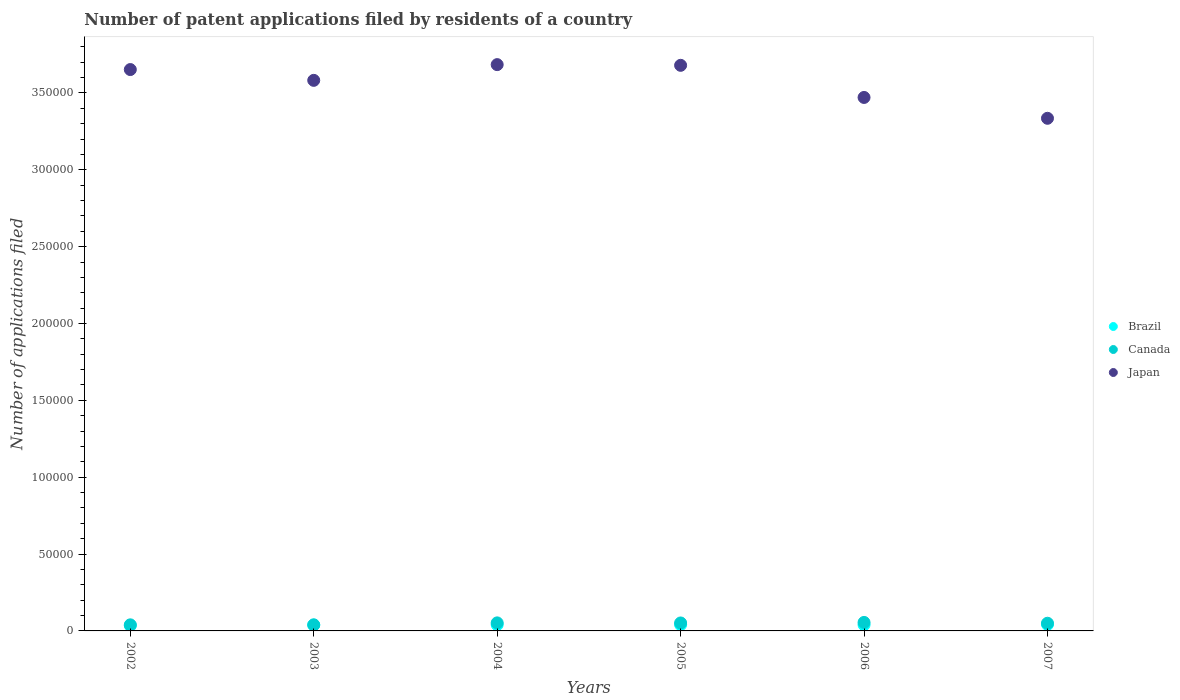What is the number of applications filed in Canada in 2004?
Your answer should be compact. 5231. Across all years, what is the maximum number of applications filed in Japan?
Ensure brevity in your answer.  3.68e+05. Across all years, what is the minimum number of applications filed in Japan?
Your answer should be very brief. 3.33e+05. In which year was the number of applications filed in Canada maximum?
Ensure brevity in your answer.  2006. What is the total number of applications filed in Brazil in the graph?
Your response must be concise. 2.36e+04. What is the difference between the number of applications filed in Brazil in 2003 and that in 2005?
Your response must be concise. -188. What is the difference between the number of applications filed in Brazil in 2004 and the number of applications filed in Canada in 2002?
Provide a short and direct response. 85. What is the average number of applications filed in Brazil per year?
Your answer should be compact. 3932.5. In the year 2006, what is the difference between the number of applications filed in Brazil and number of applications filed in Canada?
Provide a short and direct response. -1566. What is the ratio of the number of applications filed in Brazil in 2004 to that in 2006?
Your response must be concise. 1.02. What is the difference between the highest and the second highest number of applications filed in Japan?
Keep it short and to the point. 456. What is the difference between the highest and the lowest number of applications filed in Japan?
Provide a short and direct response. 3.49e+04. Is the number of applications filed in Japan strictly less than the number of applications filed in Canada over the years?
Offer a terse response. No. How many dotlines are there?
Your answer should be very brief. 3. What is the difference between two consecutive major ticks on the Y-axis?
Your response must be concise. 5.00e+04. Are the values on the major ticks of Y-axis written in scientific E-notation?
Provide a succinct answer. No. Does the graph contain any zero values?
Give a very brief answer. No. Where does the legend appear in the graph?
Offer a terse response. Center right. How many legend labels are there?
Your answer should be compact. 3. How are the legend labels stacked?
Offer a very short reply. Vertical. What is the title of the graph?
Make the answer very short. Number of patent applications filed by residents of a country. What is the label or title of the X-axis?
Keep it short and to the point. Years. What is the label or title of the Y-axis?
Offer a terse response. Number of applications filed. What is the Number of applications filed of Brazil in 2002?
Your answer should be very brief. 3481. What is the Number of applications filed in Canada in 2002?
Your answer should be very brief. 3959. What is the Number of applications filed in Japan in 2002?
Offer a terse response. 3.65e+05. What is the Number of applications filed of Brazil in 2003?
Offer a terse response. 3866. What is the Number of applications filed of Canada in 2003?
Your answer should be compact. 3929. What is the Number of applications filed in Japan in 2003?
Offer a terse response. 3.58e+05. What is the Number of applications filed in Brazil in 2004?
Give a very brief answer. 4044. What is the Number of applications filed of Canada in 2004?
Provide a succinct answer. 5231. What is the Number of applications filed of Japan in 2004?
Your response must be concise. 3.68e+05. What is the Number of applications filed in Brazil in 2005?
Provide a short and direct response. 4054. What is the Number of applications filed in Canada in 2005?
Keep it short and to the point. 5183. What is the Number of applications filed of Japan in 2005?
Your response must be concise. 3.68e+05. What is the Number of applications filed in Brazil in 2006?
Your answer should be very brief. 3956. What is the Number of applications filed of Canada in 2006?
Keep it short and to the point. 5522. What is the Number of applications filed in Japan in 2006?
Give a very brief answer. 3.47e+05. What is the Number of applications filed of Brazil in 2007?
Your answer should be very brief. 4194. What is the Number of applications filed of Canada in 2007?
Make the answer very short. 4998. What is the Number of applications filed in Japan in 2007?
Make the answer very short. 3.33e+05. Across all years, what is the maximum Number of applications filed in Brazil?
Offer a terse response. 4194. Across all years, what is the maximum Number of applications filed of Canada?
Provide a succinct answer. 5522. Across all years, what is the maximum Number of applications filed in Japan?
Give a very brief answer. 3.68e+05. Across all years, what is the minimum Number of applications filed of Brazil?
Provide a succinct answer. 3481. Across all years, what is the minimum Number of applications filed in Canada?
Your answer should be compact. 3929. Across all years, what is the minimum Number of applications filed in Japan?
Provide a succinct answer. 3.33e+05. What is the total Number of applications filed in Brazil in the graph?
Provide a succinct answer. 2.36e+04. What is the total Number of applications filed in Canada in the graph?
Make the answer very short. 2.88e+04. What is the total Number of applications filed in Japan in the graph?
Make the answer very short. 2.14e+06. What is the difference between the Number of applications filed in Brazil in 2002 and that in 2003?
Your answer should be very brief. -385. What is the difference between the Number of applications filed in Japan in 2002 and that in 2003?
Give a very brief answer. 7020. What is the difference between the Number of applications filed in Brazil in 2002 and that in 2004?
Offer a very short reply. -563. What is the difference between the Number of applications filed of Canada in 2002 and that in 2004?
Provide a succinct answer. -1272. What is the difference between the Number of applications filed of Japan in 2002 and that in 2004?
Provide a succinct answer. -3212. What is the difference between the Number of applications filed of Brazil in 2002 and that in 2005?
Give a very brief answer. -573. What is the difference between the Number of applications filed of Canada in 2002 and that in 2005?
Ensure brevity in your answer.  -1224. What is the difference between the Number of applications filed of Japan in 2002 and that in 2005?
Your answer should be compact. -2756. What is the difference between the Number of applications filed in Brazil in 2002 and that in 2006?
Make the answer very short. -475. What is the difference between the Number of applications filed in Canada in 2002 and that in 2006?
Provide a short and direct response. -1563. What is the difference between the Number of applications filed of Japan in 2002 and that in 2006?
Give a very brief answer. 1.81e+04. What is the difference between the Number of applications filed of Brazil in 2002 and that in 2007?
Your response must be concise. -713. What is the difference between the Number of applications filed in Canada in 2002 and that in 2007?
Give a very brief answer. -1039. What is the difference between the Number of applications filed in Japan in 2002 and that in 2007?
Keep it short and to the point. 3.17e+04. What is the difference between the Number of applications filed of Brazil in 2003 and that in 2004?
Your answer should be compact. -178. What is the difference between the Number of applications filed of Canada in 2003 and that in 2004?
Give a very brief answer. -1302. What is the difference between the Number of applications filed in Japan in 2003 and that in 2004?
Provide a short and direct response. -1.02e+04. What is the difference between the Number of applications filed in Brazil in 2003 and that in 2005?
Your answer should be very brief. -188. What is the difference between the Number of applications filed of Canada in 2003 and that in 2005?
Offer a very short reply. -1254. What is the difference between the Number of applications filed of Japan in 2003 and that in 2005?
Offer a very short reply. -9776. What is the difference between the Number of applications filed in Brazil in 2003 and that in 2006?
Provide a short and direct response. -90. What is the difference between the Number of applications filed in Canada in 2003 and that in 2006?
Give a very brief answer. -1593. What is the difference between the Number of applications filed of Japan in 2003 and that in 2006?
Provide a succinct answer. 1.11e+04. What is the difference between the Number of applications filed of Brazil in 2003 and that in 2007?
Your answer should be very brief. -328. What is the difference between the Number of applications filed of Canada in 2003 and that in 2007?
Provide a short and direct response. -1069. What is the difference between the Number of applications filed in Japan in 2003 and that in 2007?
Keep it short and to the point. 2.47e+04. What is the difference between the Number of applications filed in Brazil in 2004 and that in 2005?
Give a very brief answer. -10. What is the difference between the Number of applications filed in Japan in 2004 and that in 2005?
Offer a terse response. 456. What is the difference between the Number of applications filed of Canada in 2004 and that in 2006?
Make the answer very short. -291. What is the difference between the Number of applications filed in Japan in 2004 and that in 2006?
Provide a succinct answer. 2.14e+04. What is the difference between the Number of applications filed of Brazil in 2004 and that in 2007?
Your response must be concise. -150. What is the difference between the Number of applications filed of Canada in 2004 and that in 2007?
Make the answer very short. 233. What is the difference between the Number of applications filed of Japan in 2004 and that in 2007?
Keep it short and to the point. 3.49e+04. What is the difference between the Number of applications filed of Canada in 2005 and that in 2006?
Your answer should be very brief. -339. What is the difference between the Number of applications filed in Japan in 2005 and that in 2006?
Make the answer very short. 2.09e+04. What is the difference between the Number of applications filed in Brazil in 2005 and that in 2007?
Make the answer very short. -140. What is the difference between the Number of applications filed in Canada in 2005 and that in 2007?
Your response must be concise. 185. What is the difference between the Number of applications filed in Japan in 2005 and that in 2007?
Keep it short and to the point. 3.45e+04. What is the difference between the Number of applications filed in Brazil in 2006 and that in 2007?
Give a very brief answer. -238. What is the difference between the Number of applications filed in Canada in 2006 and that in 2007?
Your answer should be compact. 524. What is the difference between the Number of applications filed in Japan in 2006 and that in 2007?
Provide a short and direct response. 1.36e+04. What is the difference between the Number of applications filed in Brazil in 2002 and the Number of applications filed in Canada in 2003?
Your answer should be compact. -448. What is the difference between the Number of applications filed in Brazil in 2002 and the Number of applications filed in Japan in 2003?
Offer a terse response. -3.55e+05. What is the difference between the Number of applications filed in Canada in 2002 and the Number of applications filed in Japan in 2003?
Provide a succinct answer. -3.54e+05. What is the difference between the Number of applications filed of Brazil in 2002 and the Number of applications filed of Canada in 2004?
Provide a succinct answer. -1750. What is the difference between the Number of applications filed in Brazil in 2002 and the Number of applications filed in Japan in 2004?
Your answer should be very brief. -3.65e+05. What is the difference between the Number of applications filed of Canada in 2002 and the Number of applications filed of Japan in 2004?
Make the answer very short. -3.64e+05. What is the difference between the Number of applications filed in Brazil in 2002 and the Number of applications filed in Canada in 2005?
Make the answer very short. -1702. What is the difference between the Number of applications filed in Brazil in 2002 and the Number of applications filed in Japan in 2005?
Provide a short and direct response. -3.64e+05. What is the difference between the Number of applications filed in Canada in 2002 and the Number of applications filed in Japan in 2005?
Make the answer very short. -3.64e+05. What is the difference between the Number of applications filed of Brazil in 2002 and the Number of applications filed of Canada in 2006?
Provide a succinct answer. -2041. What is the difference between the Number of applications filed in Brazil in 2002 and the Number of applications filed in Japan in 2006?
Keep it short and to the point. -3.44e+05. What is the difference between the Number of applications filed of Canada in 2002 and the Number of applications filed of Japan in 2006?
Make the answer very short. -3.43e+05. What is the difference between the Number of applications filed of Brazil in 2002 and the Number of applications filed of Canada in 2007?
Make the answer very short. -1517. What is the difference between the Number of applications filed of Brazil in 2002 and the Number of applications filed of Japan in 2007?
Keep it short and to the point. -3.30e+05. What is the difference between the Number of applications filed of Canada in 2002 and the Number of applications filed of Japan in 2007?
Ensure brevity in your answer.  -3.30e+05. What is the difference between the Number of applications filed of Brazil in 2003 and the Number of applications filed of Canada in 2004?
Your answer should be very brief. -1365. What is the difference between the Number of applications filed in Brazil in 2003 and the Number of applications filed in Japan in 2004?
Your response must be concise. -3.65e+05. What is the difference between the Number of applications filed of Canada in 2003 and the Number of applications filed of Japan in 2004?
Make the answer very short. -3.64e+05. What is the difference between the Number of applications filed of Brazil in 2003 and the Number of applications filed of Canada in 2005?
Give a very brief answer. -1317. What is the difference between the Number of applications filed in Brazil in 2003 and the Number of applications filed in Japan in 2005?
Give a very brief answer. -3.64e+05. What is the difference between the Number of applications filed in Canada in 2003 and the Number of applications filed in Japan in 2005?
Your answer should be compact. -3.64e+05. What is the difference between the Number of applications filed of Brazil in 2003 and the Number of applications filed of Canada in 2006?
Ensure brevity in your answer.  -1656. What is the difference between the Number of applications filed in Brazil in 2003 and the Number of applications filed in Japan in 2006?
Ensure brevity in your answer.  -3.43e+05. What is the difference between the Number of applications filed in Canada in 2003 and the Number of applications filed in Japan in 2006?
Provide a succinct answer. -3.43e+05. What is the difference between the Number of applications filed of Brazil in 2003 and the Number of applications filed of Canada in 2007?
Your response must be concise. -1132. What is the difference between the Number of applications filed of Brazil in 2003 and the Number of applications filed of Japan in 2007?
Keep it short and to the point. -3.30e+05. What is the difference between the Number of applications filed of Canada in 2003 and the Number of applications filed of Japan in 2007?
Your response must be concise. -3.30e+05. What is the difference between the Number of applications filed of Brazil in 2004 and the Number of applications filed of Canada in 2005?
Provide a succinct answer. -1139. What is the difference between the Number of applications filed of Brazil in 2004 and the Number of applications filed of Japan in 2005?
Give a very brief answer. -3.64e+05. What is the difference between the Number of applications filed in Canada in 2004 and the Number of applications filed in Japan in 2005?
Provide a succinct answer. -3.63e+05. What is the difference between the Number of applications filed of Brazil in 2004 and the Number of applications filed of Canada in 2006?
Give a very brief answer. -1478. What is the difference between the Number of applications filed in Brazil in 2004 and the Number of applications filed in Japan in 2006?
Your answer should be compact. -3.43e+05. What is the difference between the Number of applications filed of Canada in 2004 and the Number of applications filed of Japan in 2006?
Your answer should be compact. -3.42e+05. What is the difference between the Number of applications filed of Brazil in 2004 and the Number of applications filed of Canada in 2007?
Ensure brevity in your answer.  -954. What is the difference between the Number of applications filed of Brazil in 2004 and the Number of applications filed of Japan in 2007?
Your answer should be very brief. -3.29e+05. What is the difference between the Number of applications filed in Canada in 2004 and the Number of applications filed in Japan in 2007?
Ensure brevity in your answer.  -3.28e+05. What is the difference between the Number of applications filed of Brazil in 2005 and the Number of applications filed of Canada in 2006?
Provide a succinct answer. -1468. What is the difference between the Number of applications filed in Brazil in 2005 and the Number of applications filed in Japan in 2006?
Give a very brief answer. -3.43e+05. What is the difference between the Number of applications filed of Canada in 2005 and the Number of applications filed of Japan in 2006?
Offer a very short reply. -3.42e+05. What is the difference between the Number of applications filed in Brazil in 2005 and the Number of applications filed in Canada in 2007?
Your answer should be very brief. -944. What is the difference between the Number of applications filed in Brazil in 2005 and the Number of applications filed in Japan in 2007?
Provide a succinct answer. -3.29e+05. What is the difference between the Number of applications filed of Canada in 2005 and the Number of applications filed of Japan in 2007?
Offer a very short reply. -3.28e+05. What is the difference between the Number of applications filed of Brazil in 2006 and the Number of applications filed of Canada in 2007?
Provide a succinct answer. -1042. What is the difference between the Number of applications filed of Brazil in 2006 and the Number of applications filed of Japan in 2007?
Give a very brief answer. -3.30e+05. What is the difference between the Number of applications filed in Canada in 2006 and the Number of applications filed in Japan in 2007?
Provide a succinct answer. -3.28e+05. What is the average Number of applications filed of Brazil per year?
Your answer should be very brief. 3932.5. What is the average Number of applications filed of Canada per year?
Give a very brief answer. 4803.67. What is the average Number of applications filed of Japan per year?
Your answer should be very brief. 3.57e+05. In the year 2002, what is the difference between the Number of applications filed in Brazil and Number of applications filed in Canada?
Provide a succinct answer. -478. In the year 2002, what is the difference between the Number of applications filed of Brazil and Number of applications filed of Japan?
Make the answer very short. -3.62e+05. In the year 2002, what is the difference between the Number of applications filed in Canada and Number of applications filed in Japan?
Your answer should be very brief. -3.61e+05. In the year 2003, what is the difference between the Number of applications filed in Brazil and Number of applications filed in Canada?
Your response must be concise. -63. In the year 2003, what is the difference between the Number of applications filed of Brazil and Number of applications filed of Japan?
Offer a very short reply. -3.54e+05. In the year 2003, what is the difference between the Number of applications filed of Canada and Number of applications filed of Japan?
Ensure brevity in your answer.  -3.54e+05. In the year 2004, what is the difference between the Number of applications filed in Brazil and Number of applications filed in Canada?
Offer a very short reply. -1187. In the year 2004, what is the difference between the Number of applications filed of Brazil and Number of applications filed of Japan?
Offer a very short reply. -3.64e+05. In the year 2004, what is the difference between the Number of applications filed in Canada and Number of applications filed in Japan?
Ensure brevity in your answer.  -3.63e+05. In the year 2005, what is the difference between the Number of applications filed of Brazil and Number of applications filed of Canada?
Your answer should be compact. -1129. In the year 2005, what is the difference between the Number of applications filed in Brazil and Number of applications filed in Japan?
Your response must be concise. -3.64e+05. In the year 2005, what is the difference between the Number of applications filed of Canada and Number of applications filed of Japan?
Offer a very short reply. -3.63e+05. In the year 2006, what is the difference between the Number of applications filed in Brazil and Number of applications filed in Canada?
Give a very brief answer. -1566. In the year 2006, what is the difference between the Number of applications filed of Brazil and Number of applications filed of Japan?
Your answer should be very brief. -3.43e+05. In the year 2006, what is the difference between the Number of applications filed of Canada and Number of applications filed of Japan?
Your answer should be compact. -3.42e+05. In the year 2007, what is the difference between the Number of applications filed of Brazil and Number of applications filed of Canada?
Make the answer very short. -804. In the year 2007, what is the difference between the Number of applications filed of Brazil and Number of applications filed of Japan?
Your response must be concise. -3.29e+05. In the year 2007, what is the difference between the Number of applications filed of Canada and Number of applications filed of Japan?
Offer a very short reply. -3.28e+05. What is the ratio of the Number of applications filed in Brazil in 2002 to that in 2003?
Your answer should be very brief. 0.9. What is the ratio of the Number of applications filed of Canada in 2002 to that in 2003?
Ensure brevity in your answer.  1.01. What is the ratio of the Number of applications filed of Japan in 2002 to that in 2003?
Make the answer very short. 1.02. What is the ratio of the Number of applications filed of Brazil in 2002 to that in 2004?
Your answer should be compact. 0.86. What is the ratio of the Number of applications filed in Canada in 2002 to that in 2004?
Your answer should be compact. 0.76. What is the ratio of the Number of applications filed of Brazil in 2002 to that in 2005?
Provide a succinct answer. 0.86. What is the ratio of the Number of applications filed of Canada in 2002 to that in 2005?
Ensure brevity in your answer.  0.76. What is the ratio of the Number of applications filed in Brazil in 2002 to that in 2006?
Provide a succinct answer. 0.88. What is the ratio of the Number of applications filed of Canada in 2002 to that in 2006?
Offer a terse response. 0.72. What is the ratio of the Number of applications filed of Japan in 2002 to that in 2006?
Make the answer very short. 1.05. What is the ratio of the Number of applications filed of Brazil in 2002 to that in 2007?
Your answer should be very brief. 0.83. What is the ratio of the Number of applications filed in Canada in 2002 to that in 2007?
Give a very brief answer. 0.79. What is the ratio of the Number of applications filed in Japan in 2002 to that in 2007?
Offer a very short reply. 1.1. What is the ratio of the Number of applications filed of Brazil in 2003 to that in 2004?
Your answer should be very brief. 0.96. What is the ratio of the Number of applications filed in Canada in 2003 to that in 2004?
Give a very brief answer. 0.75. What is the ratio of the Number of applications filed of Japan in 2003 to that in 2004?
Provide a short and direct response. 0.97. What is the ratio of the Number of applications filed in Brazil in 2003 to that in 2005?
Give a very brief answer. 0.95. What is the ratio of the Number of applications filed of Canada in 2003 to that in 2005?
Your answer should be very brief. 0.76. What is the ratio of the Number of applications filed in Japan in 2003 to that in 2005?
Ensure brevity in your answer.  0.97. What is the ratio of the Number of applications filed of Brazil in 2003 to that in 2006?
Your answer should be very brief. 0.98. What is the ratio of the Number of applications filed in Canada in 2003 to that in 2006?
Offer a very short reply. 0.71. What is the ratio of the Number of applications filed of Japan in 2003 to that in 2006?
Provide a succinct answer. 1.03. What is the ratio of the Number of applications filed of Brazil in 2003 to that in 2007?
Your answer should be compact. 0.92. What is the ratio of the Number of applications filed of Canada in 2003 to that in 2007?
Provide a succinct answer. 0.79. What is the ratio of the Number of applications filed in Japan in 2003 to that in 2007?
Offer a terse response. 1.07. What is the ratio of the Number of applications filed of Canada in 2004 to that in 2005?
Your answer should be compact. 1.01. What is the ratio of the Number of applications filed in Brazil in 2004 to that in 2006?
Your response must be concise. 1.02. What is the ratio of the Number of applications filed in Canada in 2004 to that in 2006?
Keep it short and to the point. 0.95. What is the ratio of the Number of applications filed in Japan in 2004 to that in 2006?
Offer a terse response. 1.06. What is the ratio of the Number of applications filed in Brazil in 2004 to that in 2007?
Offer a very short reply. 0.96. What is the ratio of the Number of applications filed in Canada in 2004 to that in 2007?
Offer a very short reply. 1.05. What is the ratio of the Number of applications filed of Japan in 2004 to that in 2007?
Keep it short and to the point. 1.1. What is the ratio of the Number of applications filed in Brazil in 2005 to that in 2006?
Offer a very short reply. 1.02. What is the ratio of the Number of applications filed in Canada in 2005 to that in 2006?
Give a very brief answer. 0.94. What is the ratio of the Number of applications filed of Japan in 2005 to that in 2006?
Provide a short and direct response. 1.06. What is the ratio of the Number of applications filed in Brazil in 2005 to that in 2007?
Provide a short and direct response. 0.97. What is the ratio of the Number of applications filed in Canada in 2005 to that in 2007?
Offer a very short reply. 1.04. What is the ratio of the Number of applications filed in Japan in 2005 to that in 2007?
Provide a short and direct response. 1.1. What is the ratio of the Number of applications filed in Brazil in 2006 to that in 2007?
Your response must be concise. 0.94. What is the ratio of the Number of applications filed of Canada in 2006 to that in 2007?
Your answer should be compact. 1.1. What is the ratio of the Number of applications filed in Japan in 2006 to that in 2007?
Your response must be concise. 1.04. What is the difference between the highest and the second highest Number of applications filed in Brazil?
Offer a terse response. 140. What is the difference between the highest and the second highest Number of applications filed of Canada?
Give a very brief answer. 291. What is the difference between the highest and the second highest Number of applications filed of Japan?
Your answer should be very brief. 456. What is the difference between the highest and the lowest Number of applications filed in Brazil?
Give a very brief answer. 713. What is the difference between the highest and the lowest Number of applications filed in Canada?
Your answer should be compact. 1593. What is the difference between the highest and the lowest Number of applications filed of Japan?
Offer a terse response. 3.49e+04. 